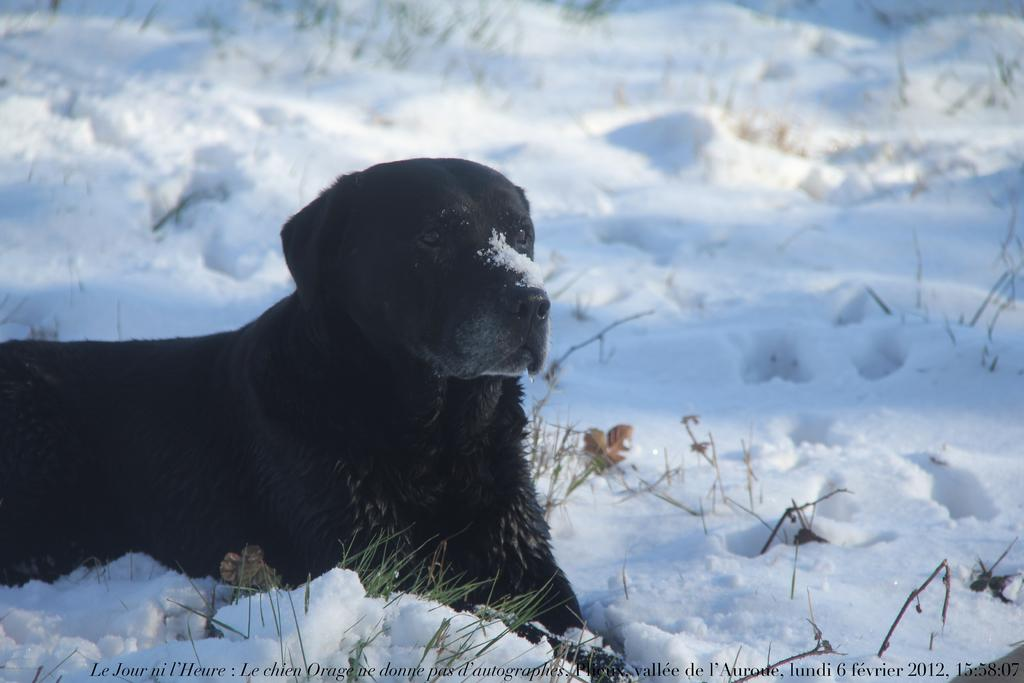What type of animal is in the image? There is a dog in the image. What is the setting of the image? The image depicts snow. What holiday is being celebrated in the image? There is no indication of a holiday being celebrated in the image. How many donkeys are present in the image? There are no donkeys present in the image. 